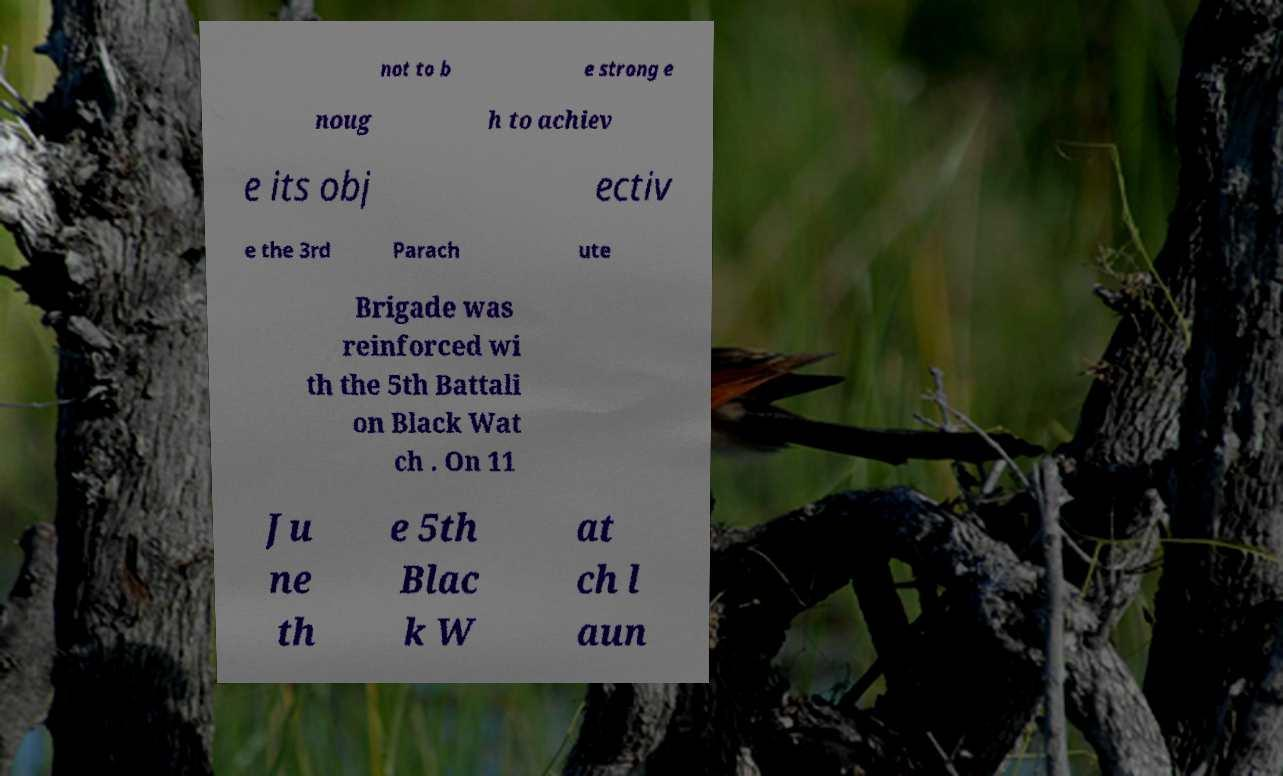Please identify and transcribe the text found in this image. not to b e strong e noug h to achiev e its obj ectiv e the 3rd Parach ute Brigade was reinforced wi th the 5th Battali on Black Wat ch . On 11 Ju ne th e 5th Blac k W at ch l aun 